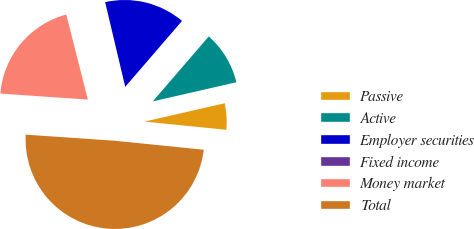Convert chart to OTSL. <chart><loc_0><loc_0><loc_500><loc_500><pie_chart><fcel>Passive<fcel>Active<fcel>Employer securities<fcel>Fixed income<fcel>Money market<fcel>Total<nl><fcel>5.18%<fcel>10.1%<fcel>15.03%<fcel>0.25%<fcel>19.95%<fcel>49.49%<nl></chart> 